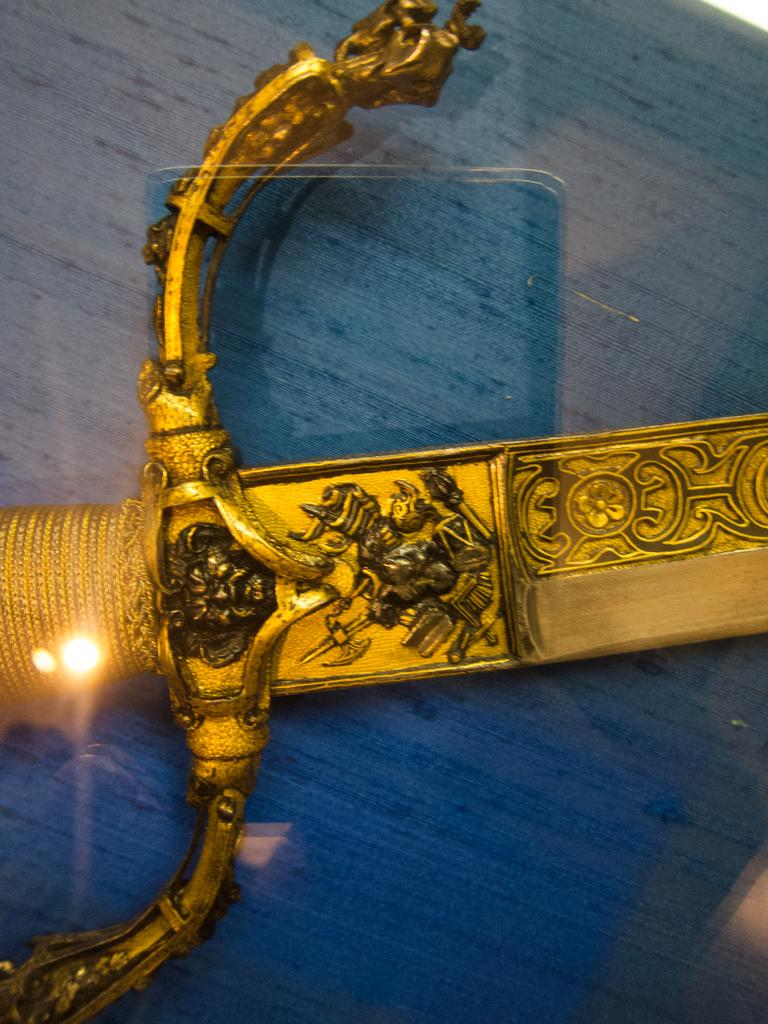What object can be seen in the image? There is a knife in the image. Where is the knife located? The knife is on a table. How many cacti are present on the table with the knife? There is no cactus present on the table with the knife; only the knife is visible. What type of snails can be seen interacting with the knife in the image? There are no snails present in the image, and the knife is not interacting with any living creatures. 